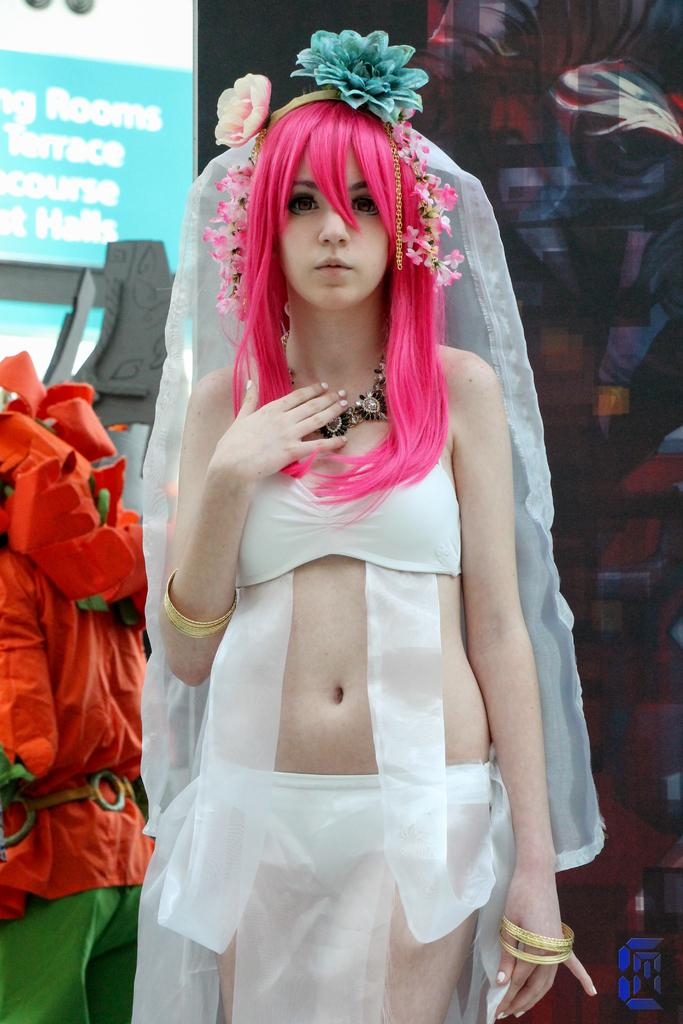What is the main subject of the image? There is a mannequin in the image. What is the mannequin wearing? The mannequin is wearing a white dress and a head ware. What other objects or elements can be seen in the image? There are flowers, a board in the background, and writing on the board. Can you tell me how many buttons are on the mannequin's dress? There is no mention of buttons on the mannequin's dress in the provided facts, so we cannot determine the number of buttons. 